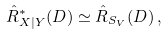<formula> <loc_0><loc_0><loc_500><loc_500>\hat { R } ^ { \ast } _ { X | Y } ( D ) \simeq \hat { R } _ { S _ { V } } ( D ) \, ,</formula> 